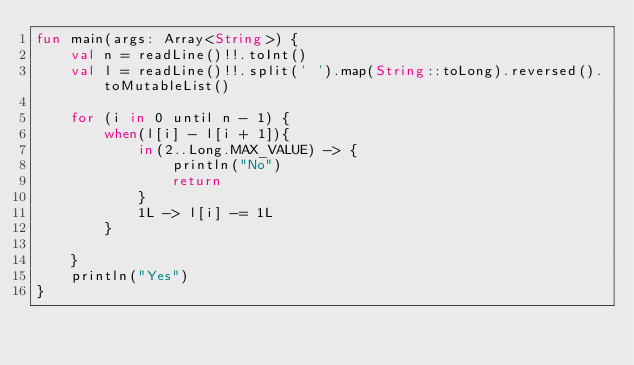Convert code to text. <code><loc_0><loc_0><loc_500><loc_500><_Kotlin_>fun main(args: Array<String>) {
    val n = readLine()!!.toInt()
    val l = readLine()!!.split(' ').map(String::toLong).reversed().toMutableList()

    for (i in 0 until n - 1) {
        when(l[i] - l[i + 1]){
            in(2..Long.MAX_VALUE) -> {
                println("No")
                return
            }
            1L -> l[i] -= 1L
        }

    }
    println("Yes")
}
</code> 